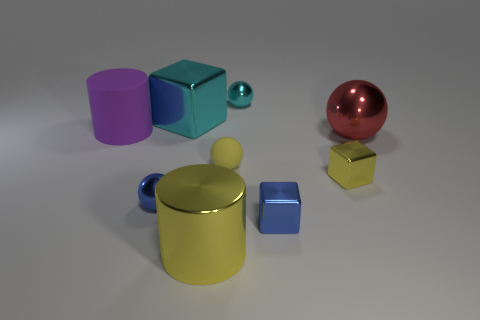Subtract all blue balls. How many balls are left? 3 Add 1 metallic balls. How many objects exist? 10 Subtract all cyan balls. How many balls are left? 3 Subtract all cylinders. How many objects are left? 7 Subtract all gray cubes. Subtract all cyan cylinders. How many cubes are left? 3 Subtract all green cubes. How many yellow cylinders are left? 1 Subtract all large metal spheres. Subtract all purple matte blocks. How many objects are left? 8 Add 6 cyan blocks. How many cyan blocks are left? 7 Add 3 tiny green matte blocks. How many tiny green matte blocks exist? 3 Subtract 1 blue spheres. How many objects are left? 8 